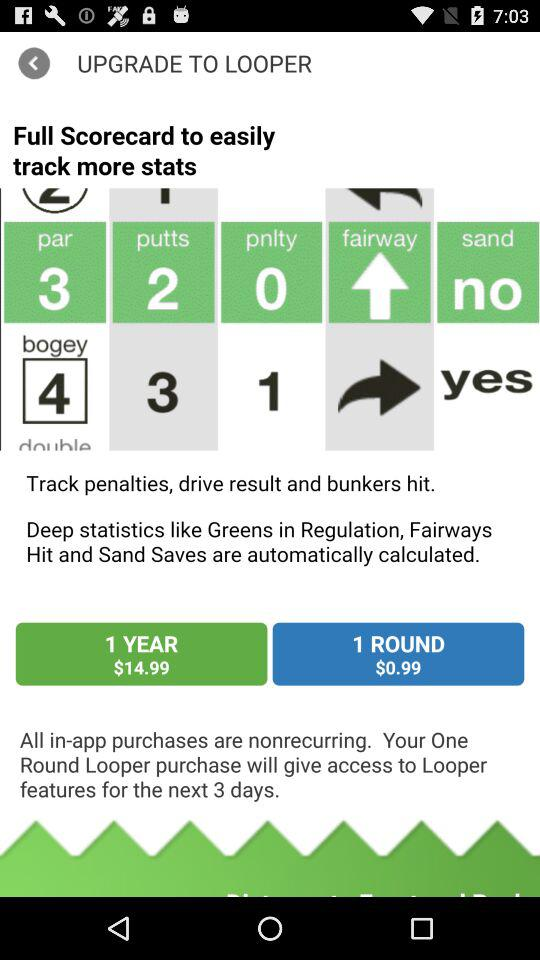What is the application name? The application name is "LOOPER". 